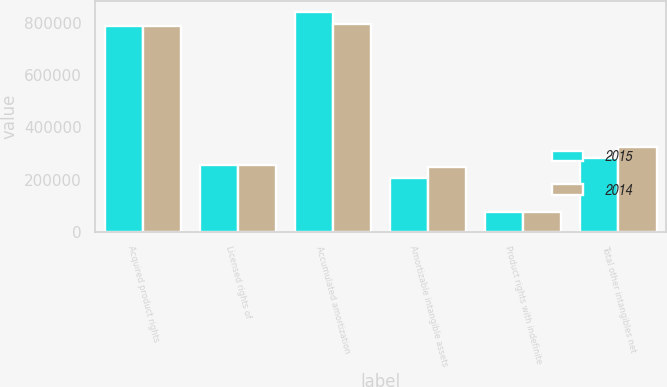<chart> <loc_0><loc_0><loc_500><loc_500><stacked_bar_chart><ecel><fcel>Acquired product rights<fcel>Licensed rights of<fcel>Accumulated amortization<fcel>Amortizable intangible assets<fcel>Product rights with indefinite<fcel>Total other intangibles net<nl><fcel>2015<fcel>789781<fcel>256555<fcel>841267<fcel>205069<fcel>75738<fcel>280807<nl><fcel>2014<fcel>789781<fcel>256555<fcel>797546<fcel>248790<fcel>75738<fcel>324528<nl></chart> 